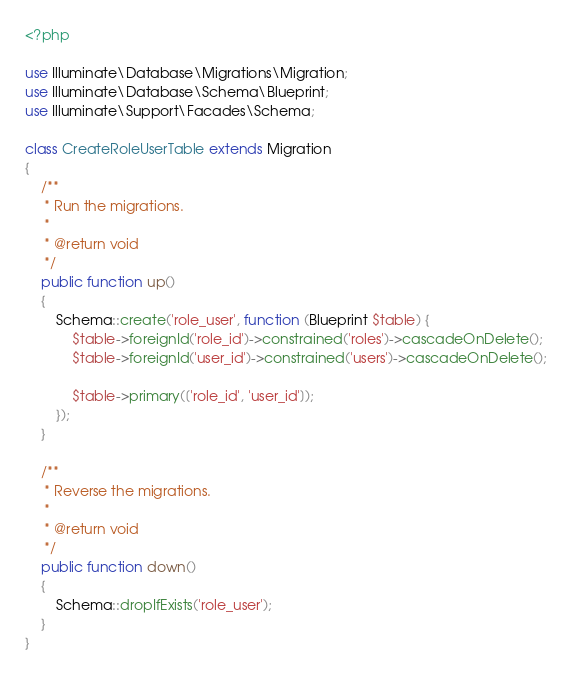Convert code to text. <code><loc_0><loc_0><loc_500><loc_500><_PHP_><?php

use Illuminate\Database\Migrations\Migration;
use Illuminate\Database\Schema\Blueprint;
use Illuminate\Support\Facades\Schema;

class CreateRoleUserTable extends Migration
{
    /**
     * Run the migrations.
     *
     * @return void
     */
    public function up()
    {
        Schema::create('role_user', function (Blueprint $table) {
            $table->foreignId('role_id')->constrained('roles')->cascadeOnDelete();
            $table->foreignId('user_id')->constrained('users')->cascadeOnDelete();
            
            $table->primary(['role_id', 'user_id']);
        });
    }

    /**
     * Reverse the migrations.
     *
     * @return void
     */
    public function down()
    {
        Schema::dropIfExists('role_user');
    }
}
</code> 